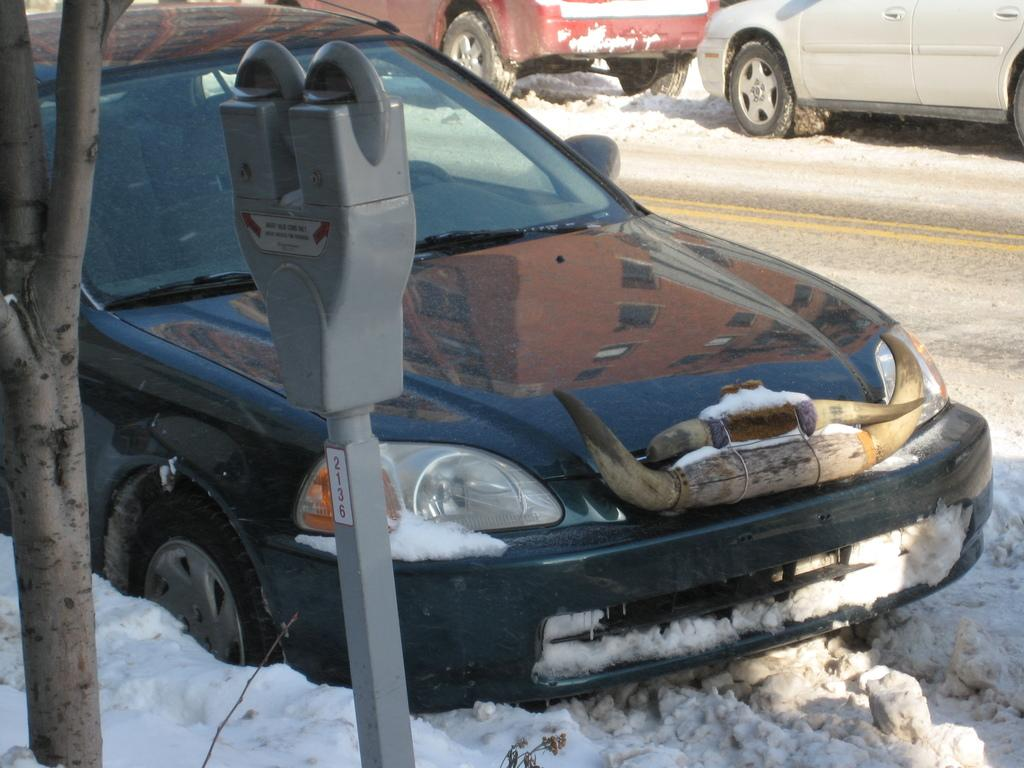What types of vehicles can be seen in the image? There are vehicles in the image, but the specific types are not mentioned. What is the condition of the ground in the image? The ground is covered with snow in the image. What is the pole used for in the image? The purpose of the pole is not mentioned in the facts. Can you describe the tree in the image? The trunk of a tree is visible in the image. What type of wing can be seen on the vehicles in the image? There is no mention of wings on the vehicles in the image. What kind of noise can be heard coming from the vehicles in the image? The facts do not mention any sounds or noises in the image. 